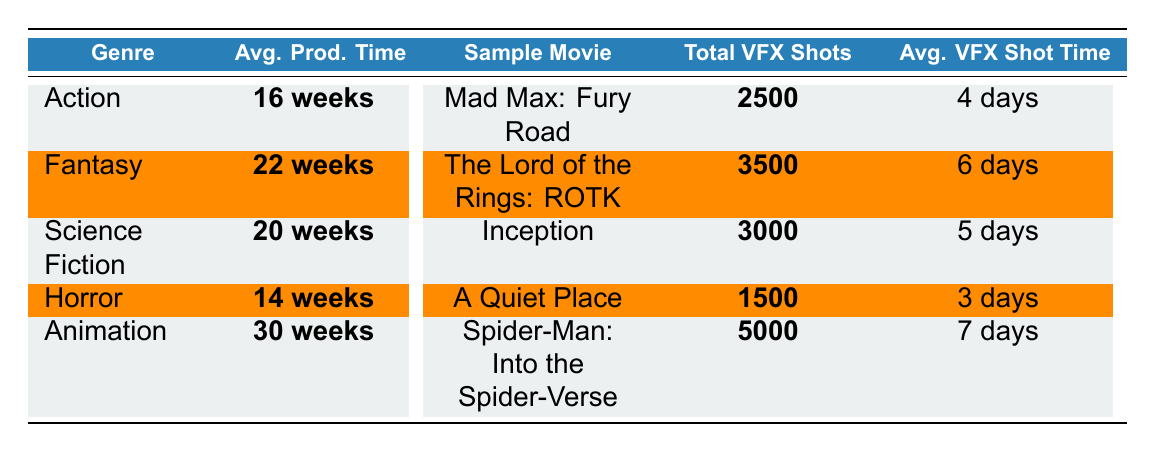What is the average production time for the Horror genre? The table indicates that the average production time for the Horror genre is listed as **14 weeks**.
Answer: 14 weeks Which genre has the highest average production time? The genres listed are Action (16 weeks), Fantasy (22 weeks), Science Fiction (20 weeks), Horror (14 weeks), and Animation (30 weeks). Among these, Animation has the highest average production time at **30 weeks**.
Answer: 30 weeks How many total VFX shots were used in the Fantasy genre? The table shows that the total VFX shots for the Fantasy genre is listed as **3500**.
Answer: 3500 What is the average shot time for the Action genre? According to the table, the average VFX shot time for the Action genre is **4 days**.
Answer: 4 days Is the average production time for Science Fiction greater than that of Horror? The average production time for Science Fiction is **20 weeks**, and for Horror, it is **14 weeks**. Since 20 weeks is greater than 14 weeks, the answer is yes.
Answer: Yes Calculate the difference in average production time between Animation and Horror. Animation has an average production time of **30 weeks** and Horror has **14 weeks**. The difference is calculated as 30 - 14 = 16 weeks.
Answer: 16 weeks What is the average number of VFX shots across all genres? To find the average, sum up the total VFX shots: 2500 (Action) + 3500 (Fantasy) + 3000 (Science Fiction) + 1500 (Horror) + 5000 (Animation) = 20000. There are 5 genres, so the average is 20000 / 5 = 4000 shots.
Answer: 4000 For which genre is the average VFX shot time the longest? The average VFX shot times are: Action (4 days), Fantasy (6 days), Science Fiction (5 days), Horror (3 days), and Animation (7 days). The longest time is for Animation at **7 days**.
Answer: 7 days Name a movie from the Science Fiction genre and its VFX time. The table lists the movie "Inception" from the Science Fiction genre, which has a VFX time of **22 weeks**.
Answer: Inception, 22 weeks Which genre has the lowest total VFX shots? The table indicates that Horror has the lowest total VFX shots at **1500** when compared to other genres.
Answer: 1500 